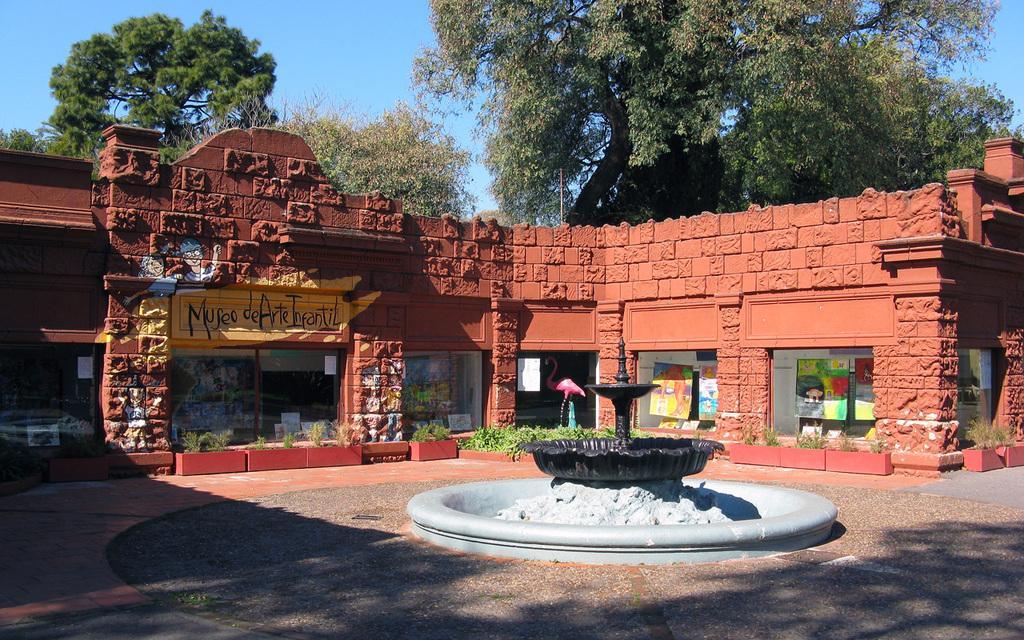Could you give a brief overview of what you see in this image? In this picture I can see the path in front and I see a fountain. In the middle of this picture I see a building and I see a boat on which there is something written and I see few plants. In the background I see number of trees and the sky. 